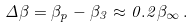Convert formula to latex. <formula><loc_0><loc_0><loc_500><loc_500>\Delta \beta = \beta _ { p } - \beta _ { 3 } \approx 0 . 2 \beta _ { \infty } \, .</formula> 